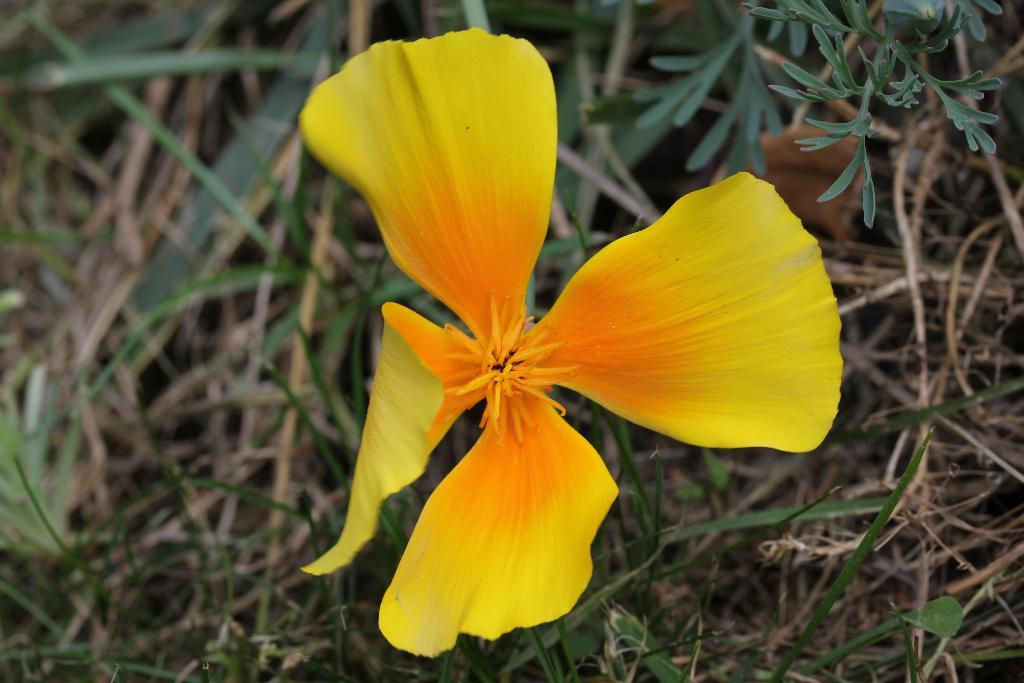What is the main subject of the image? There is a flower in the image. Can you describe the background of the image? The background of the image is blurred. What type of vegetation can be seen in the image? Dried grass and dried leaves are visible in the image. How many cats are sitting on the canvas in the image? There is no canvas or cats present in the image; it features a flower and blurred background. 